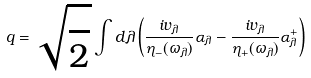<formula> <loc_0><loc_0><loc_500><loc_500>q = \sqrt { \frac { } { 2 } } \int d \lambda \left ( \frac { i v _ { \lambda } } { \eta _ { - } ( \omega _ { \lambda } ) } \alpha _ { \lambda } - \frac { i v _ { \lambda } } { \eta _ { + } ( \omega _ { \lambda } ) } \alpha _ { \lambda } ^ { + } \right )</formula> 